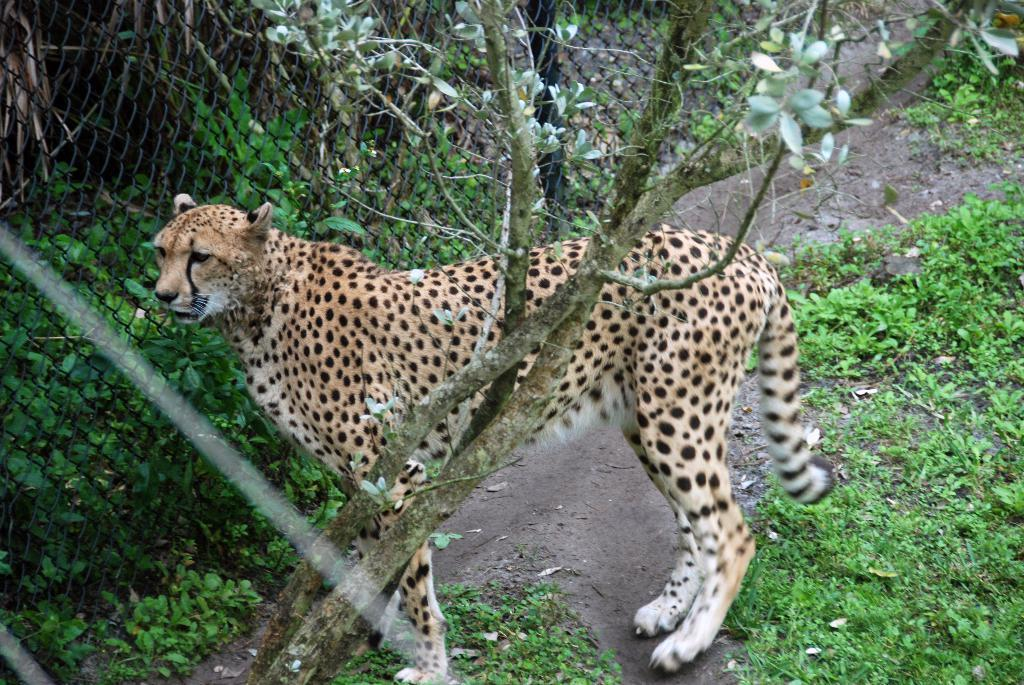What animal is standing in the image? There is a cheetah standing in the image. What is located in the foreground of the image? There is a tree in the foreground of the image. What is present in the image that separates the cheetah from the plants behind it? There is a fence in the image. What can be seen behind the fence in the image? There are plants behind the fence. What is visible at the bottom of the image? The ground is visible at the bottom of the image. What type of vegetation is present on the ground in the image? There are plants on the ground. What type of cactus is being used as a straw by the cheetah in the image? There is no cactus or straw present in the image; it features a cheetah standing near a tree and fence. 